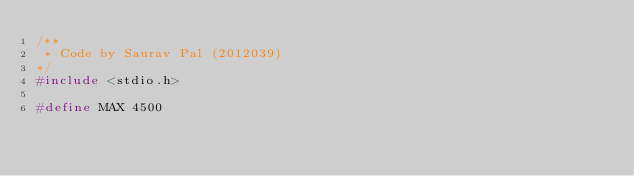Convert code to text. <code><loc_0><loc_0><loc_500><loc_500><_C_>/**
 * Code by Saurav Pal (2012039)
*/
#include <stdio.h>

#define MAX 4500
</code> 